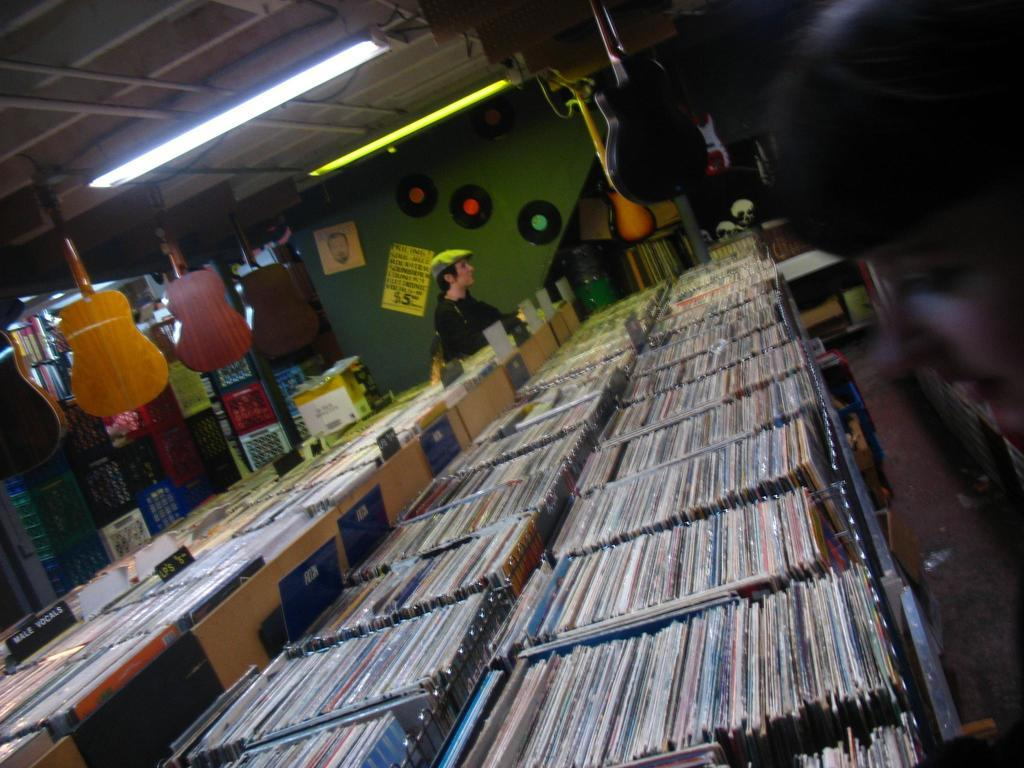What can be seen in rows in the image? There are many books in rows in the image. Who or what is located behind the books? There is a person standing behind the books. What color is the wall at the back of the image? The wall at the back of the image is green. What musical instruments are hanging in the image? Guitars are hanging on the top of the image. What type of texture can be seen on the boats in the image? There are no boats present in the image; it features rows of books, a person, a green wall, and guitars hanging on top. 